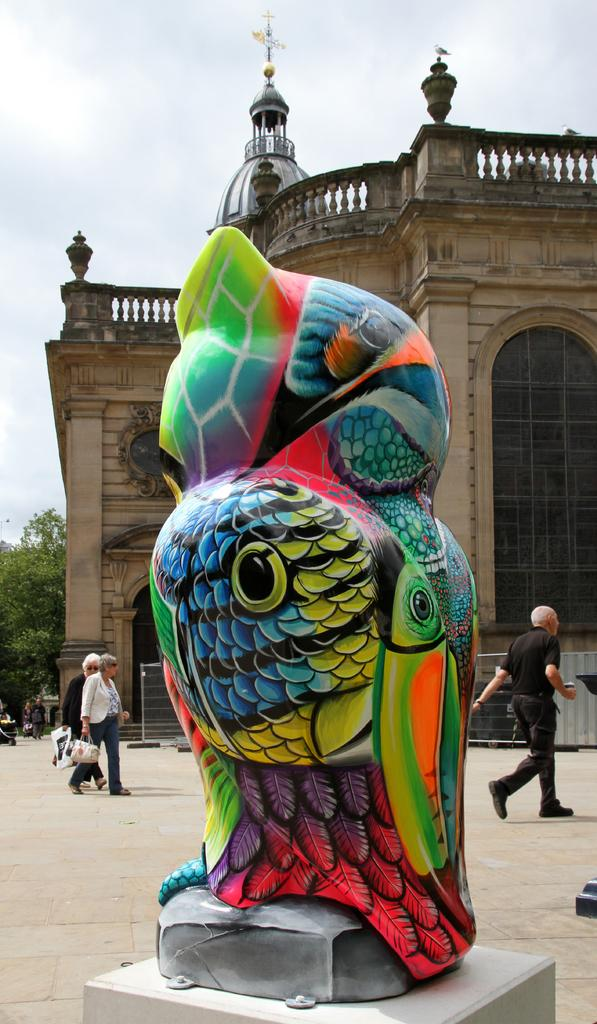What is the main subject of the image? The main subject of the image is a statue with a painting on it. What can be seen in the background of the image? There is a building, a tree, and the sky visible in the background of the image. What are the people in the background doing? The people in the background are walking and holding bags. What is the condition of the sky in the image? The sky is cloudy in the image. What type of education can be seen taking place at the seashore in the image? There is no seashore present in the image, and therefore no educational activities can be observed. What thing is being used by the people in the image to communicate with each other? There is no specific thing being used by the people in the image to communicate with each other; they are simply walking and holding bags. 